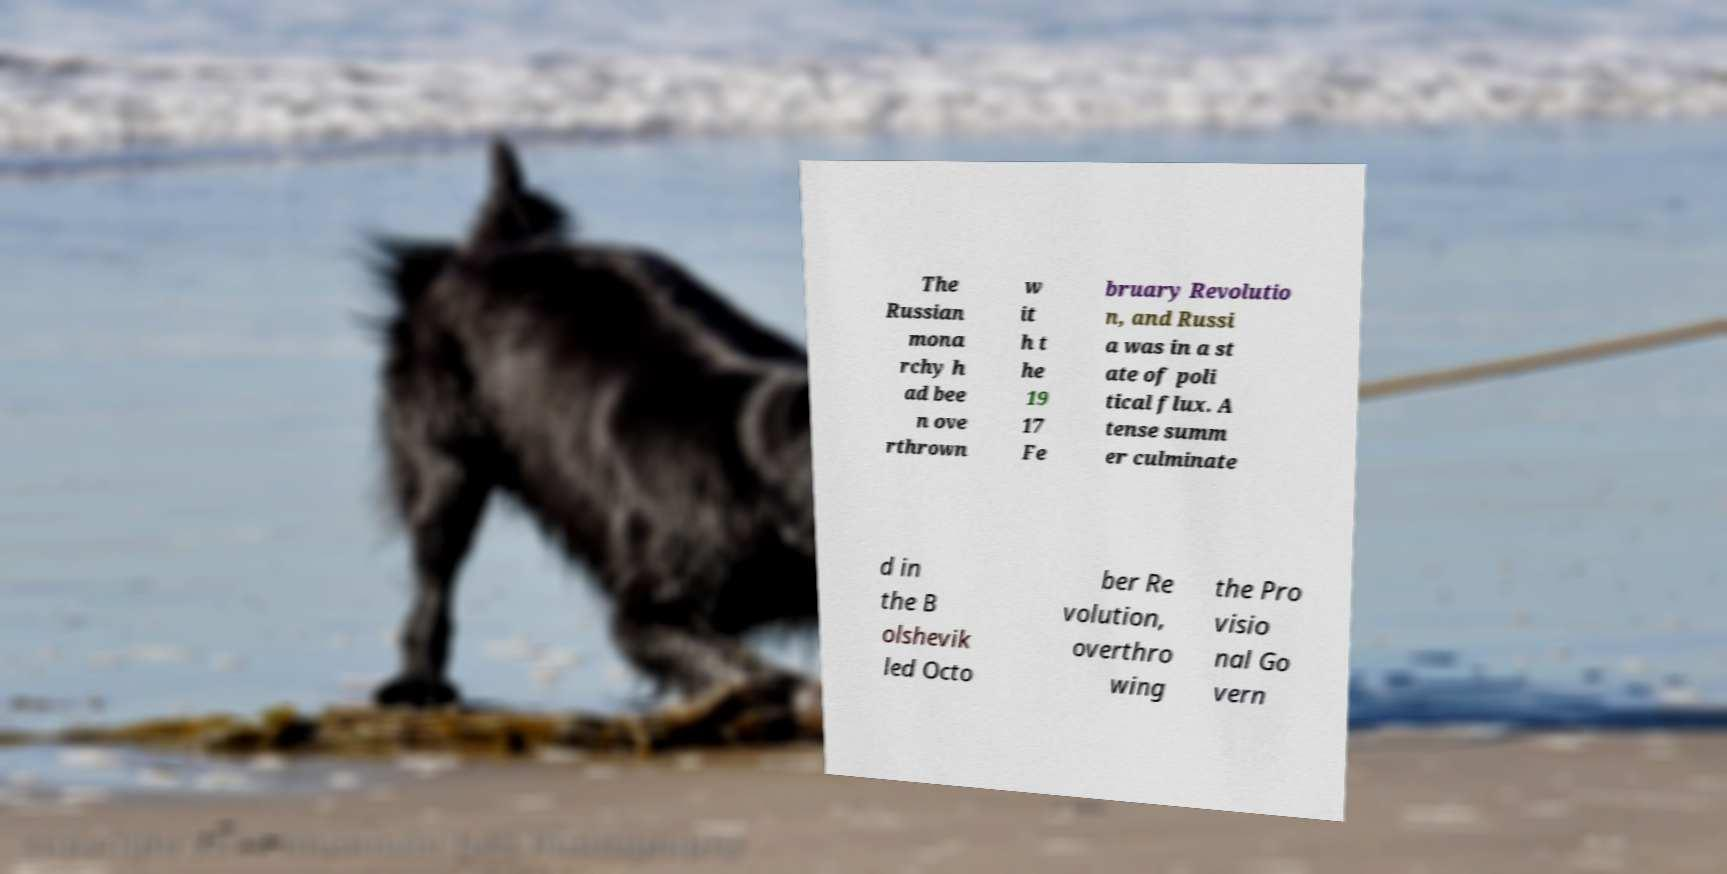Can you read and provide the text displayed in the image?This photo seems to have some interesting text. Can you extract and type it out for me? The Russian mona rchy h ad bee n ove rthrown w it h t he 19 17 Fe bruary Revolutio n, and Russi a was in a st ate of poli tical flux. A tense summ er culminate d in the B olshevik led Octo ber Re volution, overthro wing the Pro visio nal Go vern 